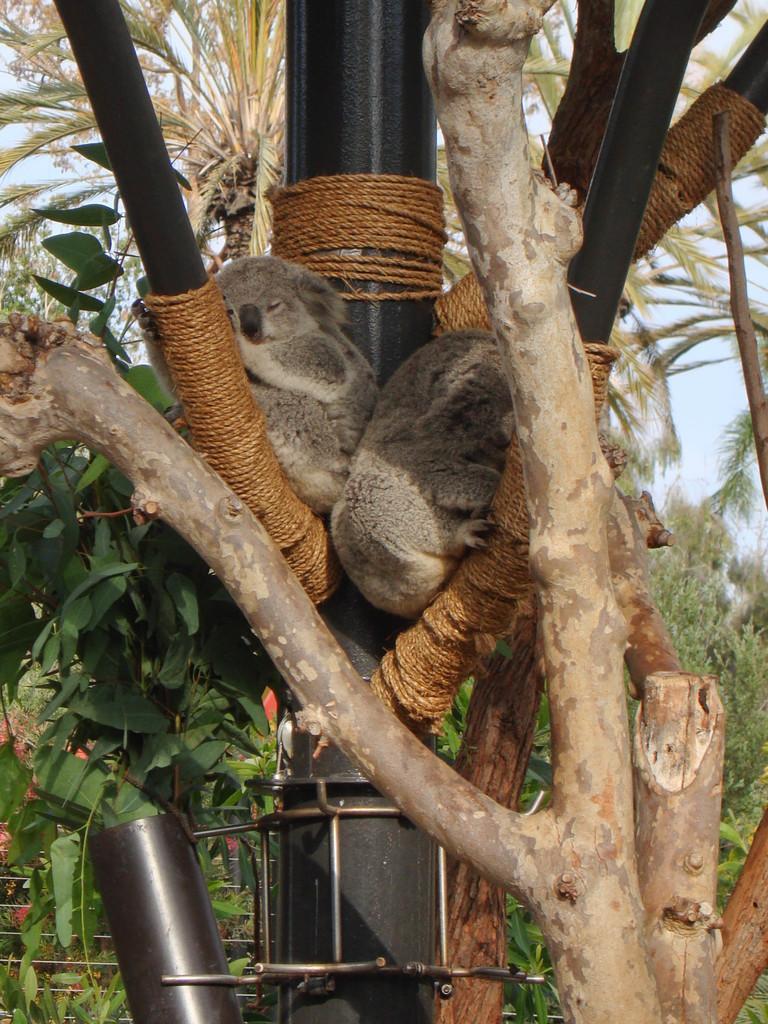Describe this image in one or two sentences. In the image we can see there are trees and in between a tree there is a black metal pole where two koalas are sleeping and the black metal pole is tied around with a rope. 